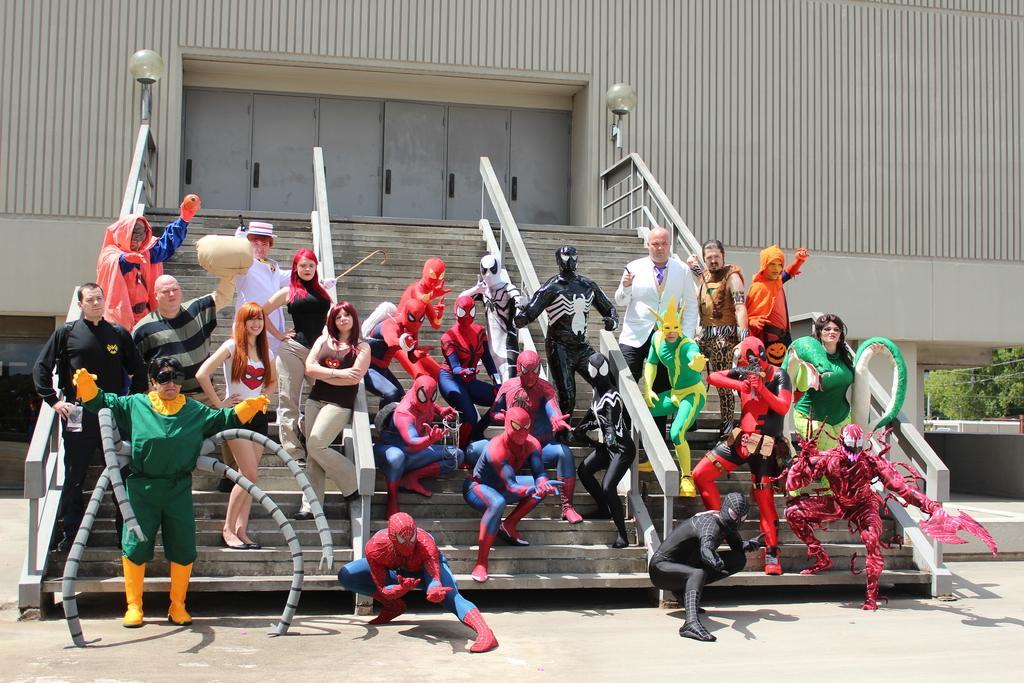Please provide a concise description of this image. In this image there are group of people in fancy dresses are standing on the stairs , and there is a building and there are trees. 